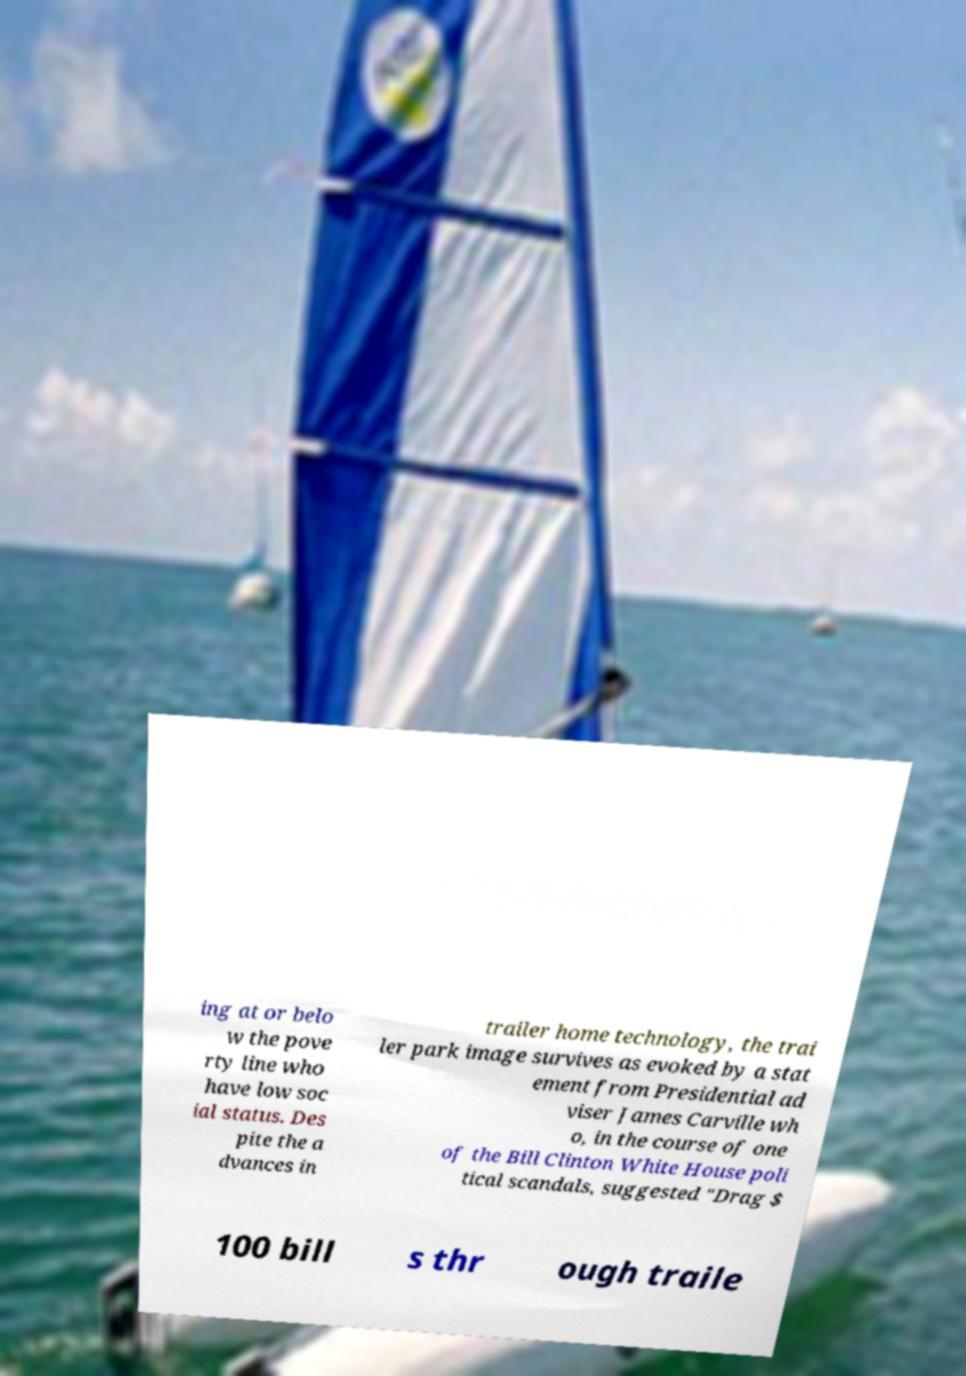Could you extract and type out the text from this image? ing at or belo w the pove rty line who have low soc ial status. Des pite the a dvances in trailer home technology, the trai ler park image survives as evoked by a stat ement from Presidential ad viser James Carville wh o, in the course of one of the Bill Clinton White House poli tical scandals, suggested "Drag $ 100 bill s thr ough traile 